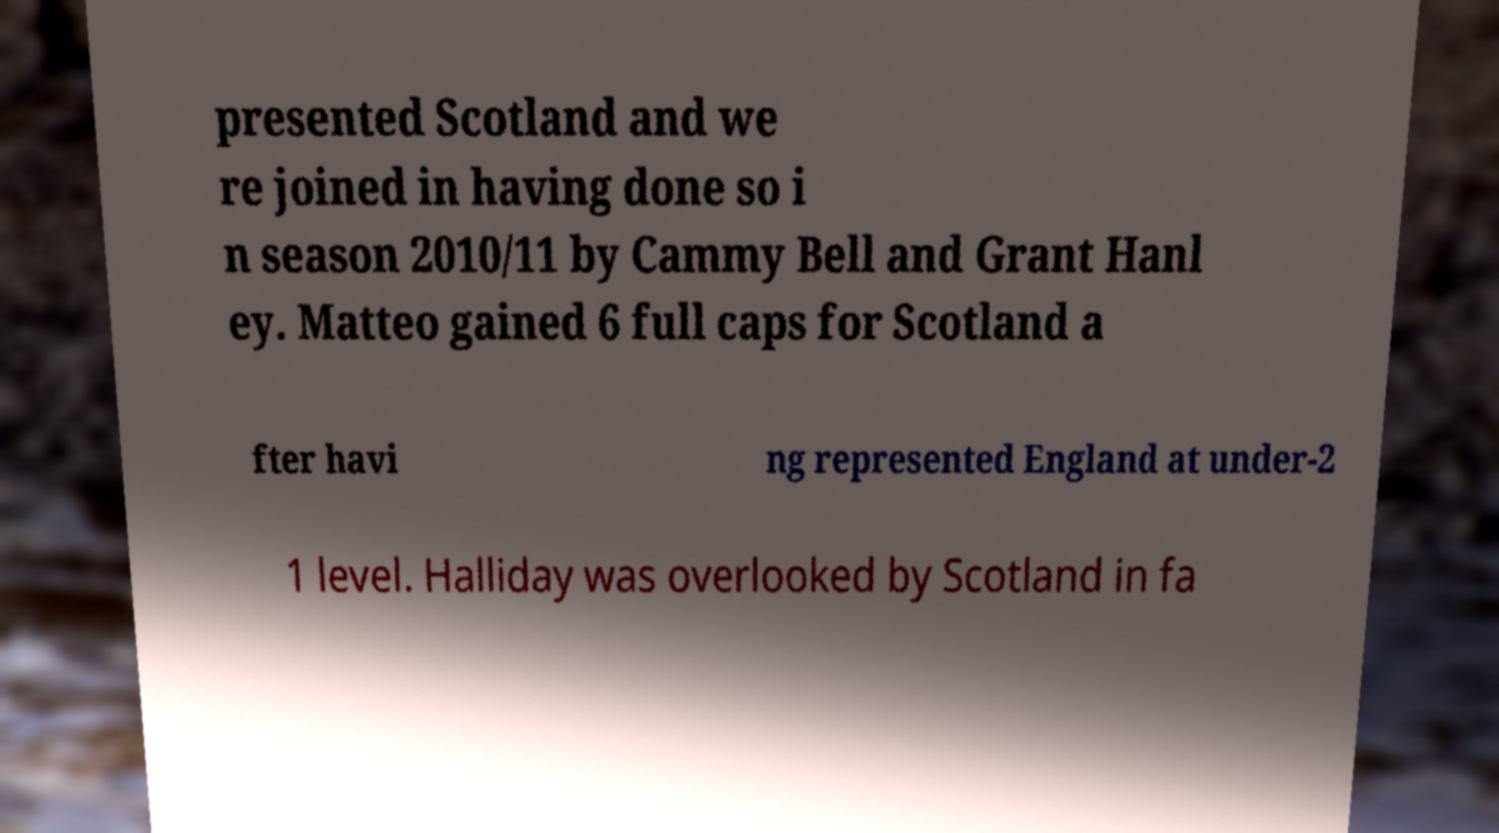I need the written content from this picture converted into text. Can you do that? presented Scotland and we re joined in having done so i n season 2010/11 by Cammy Bell and Grant Hanl ey. Matteo gained 6 full caps for Scotland a fter havi ng represented England at under-2 1 level. Halliday was overlooked by Scotland in fa 